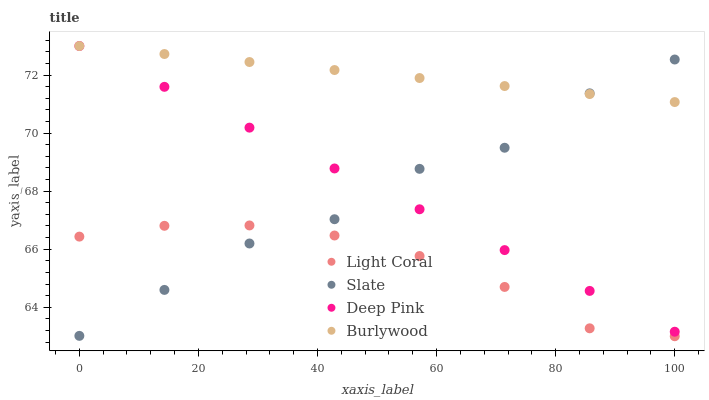Does Light Coral have the minimum area under the curve?
Answer yes or no. Yes. Does Burlywood have the maximum area under the curve?
Answer yes or no. Yes. Does Slate have the minimum area under the curve?
Answer yes or no. No. Does Slate have the maximum area under the curve?
Answer yes or no. No. Is Burlywood the smoothest?
Answer yes or no. Yes. Is Slate the roughest?
Answer yes or no. Yes. Is Slate the smoothest?
Answer yes or no. No. Is Burlywood the roughest?
Answer yes or no. No. Does Light Coral have the lowest value?
Answer yes or no. Yes. Does Slate have the lowest value?
Answer yes or no. No. Does Deep Pink have the highest value?
Answer yes or no. Yes. Does Slate have the highest value?
Answer yes or no. No. Is Light Coral less than Burlywood?
Answer yes or no. Yes. Is Burlywood greater than Light Coral?
Answer yes or no. Yes. Does Slate intersect Deep Pink?
Answer yes or no. Yes. Is Slate less than Deep Pink?
Answer yes or no. No. Is Slate greater than Deep Pink?
Answer yes or no. No. Does Light Coral intersect Burlywood?
Answer yes or no. No. 